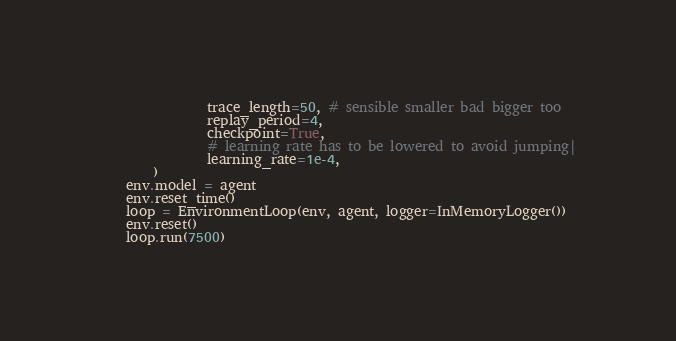<code> <loc_0><loc_0><loc_500><loc_500><_Python_>                trace_length=50, # sensible smaller bad bigger too
                replay_period=4,
                checkpoint=True,
                # learning rate has to be lowered to avoid jumping|
                learning_rate=1e-4,
        )
    env.model = agent
    env.reset_time()
    loop = EnvironmentLoop(env, agent, logger=InMemoryLogger())
    env.reset()
    loop.run(7500)
</code> 